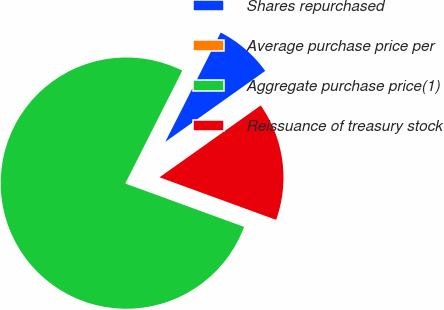Convert chart. <chart><loc_0><loc_0><loc_500><loc_500><pie_chart><fcel>Shares repurchased<fcel>Average purchase price per<fcel>Aggregate purchase price(1)<fcel>Reissuance of treasury stock<nl><fcel>7.71%<fcel>0.02%<fcel>76.88%<fcel>15.39%<nl></chart> 